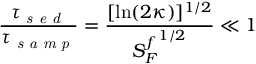Convert formula to latex. <formula><loc_0><loc_0><loc_500><loc_500>\frac { \tau _ { s e d } } { \tau _ { s a m p } } = \frac { [ \ln ( 2 \kappa ) ] ^ { 1 / 2 } } { { S _ { F } ^ { f } } ^ { 1 / 2 } } \ll 1</formula> 